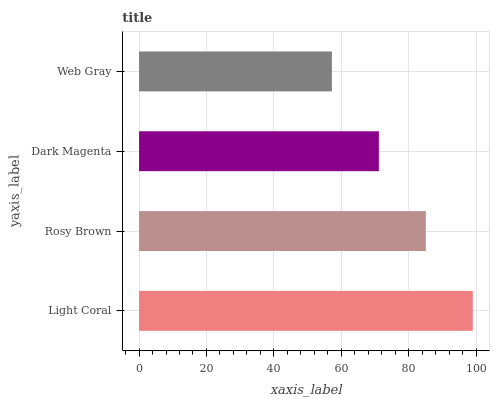Is Web Gray the minimum?
Answer yes or no. Yes. Is Light Coral the maximum?
Answer yes or no. Yes. Is Rosy Brown the minimum?
Answer yes or no. No. Is Rosy Brown the maximum?
Answer yes or no. No. Is Light Coral greater than Rosy Brown?
Answer yes or no. Yes. Is Rosy Brown less than Light Coral?
Answer yes or no. Yes. Is Rosy Brown greater than Light Coral?
Answer yes or no. No. Is Light Coral less than Rosy Brown?
Answer yes or no. No. Is Rosy Brown the high median?
Answer yes or no. Yes. Is Dark Magenta the low median?
Answer yes or no. Yes. Is Light Coral the high median?
Answer yes or no. No. Is Rosy Brown the low median?
Answer yes or no. No. 